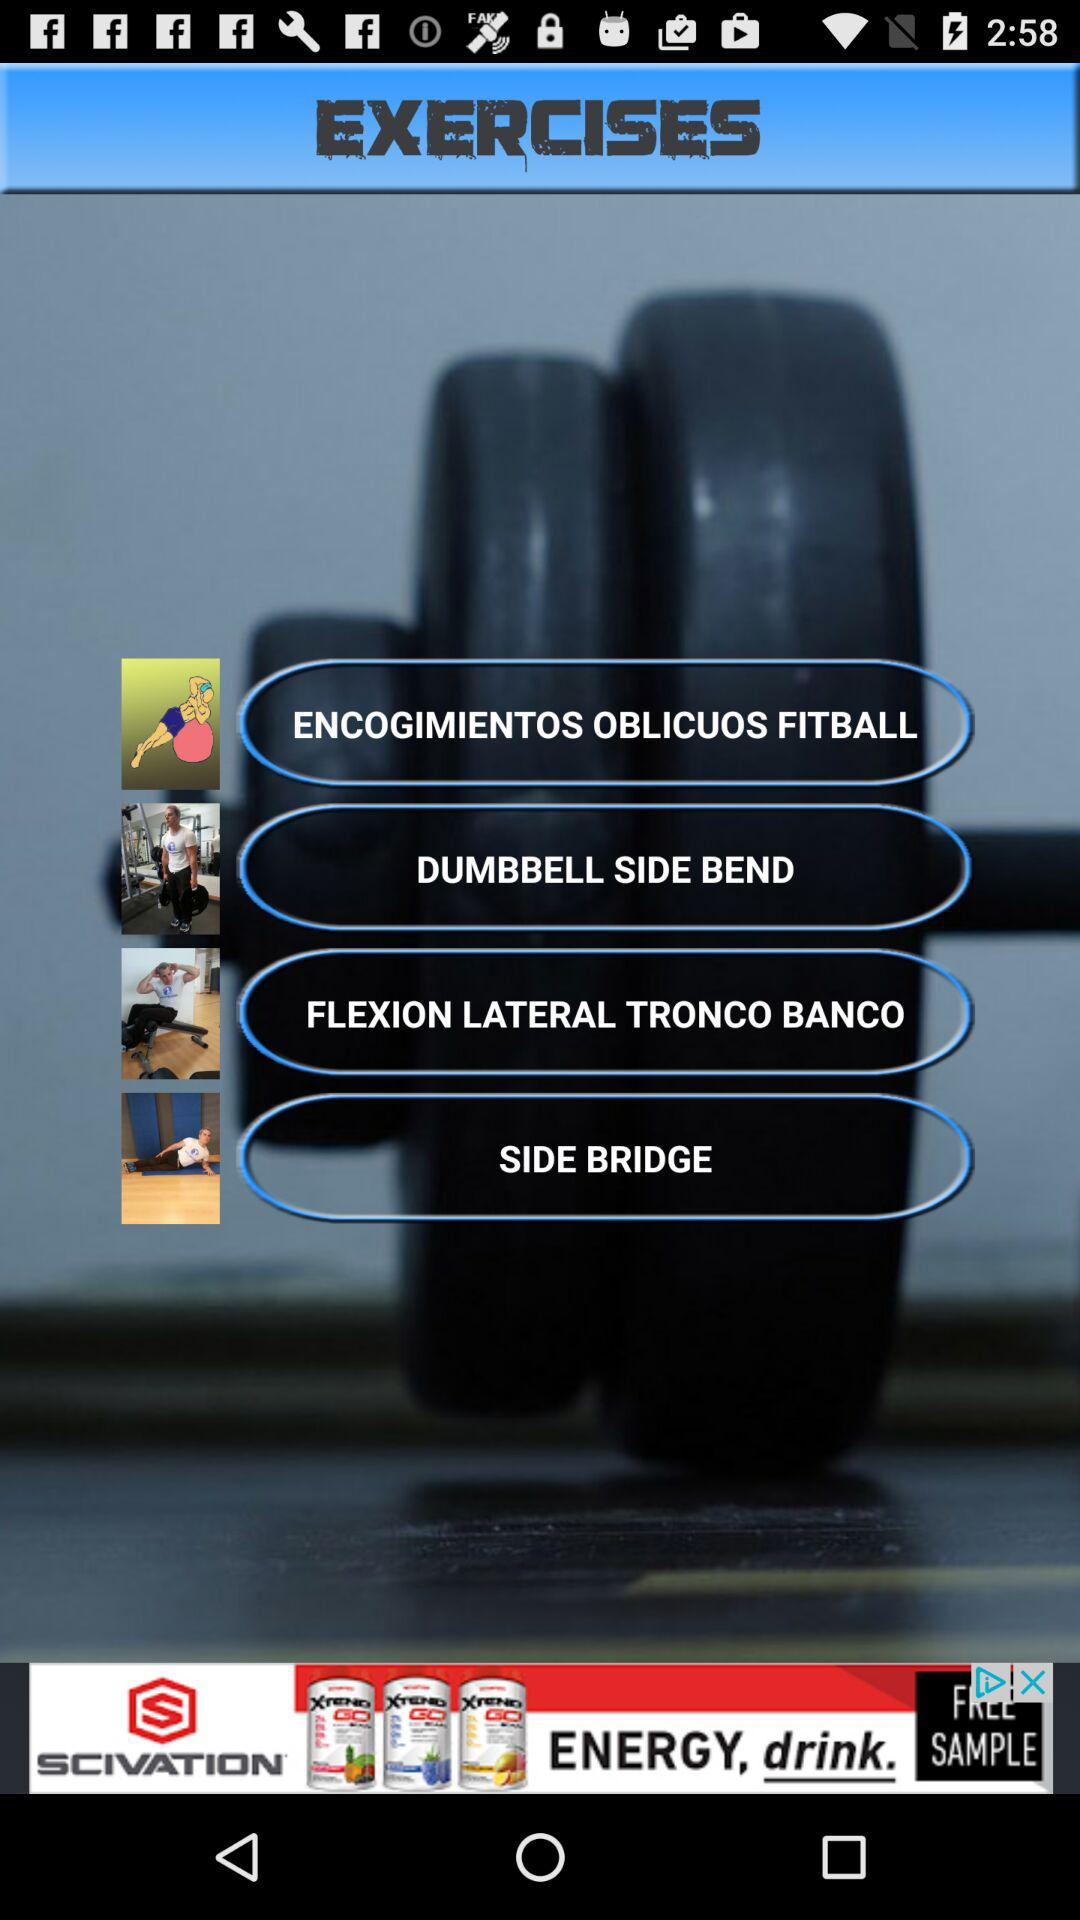What are the different exercises available? The different exercises available are "ENCOGIMIENTOS OBLICUOS FITBALL", "DUMBBELL SIDE BEND", "FLEXION LATERAL TRONCO BANCO" and "SIDE BRIDGE". 